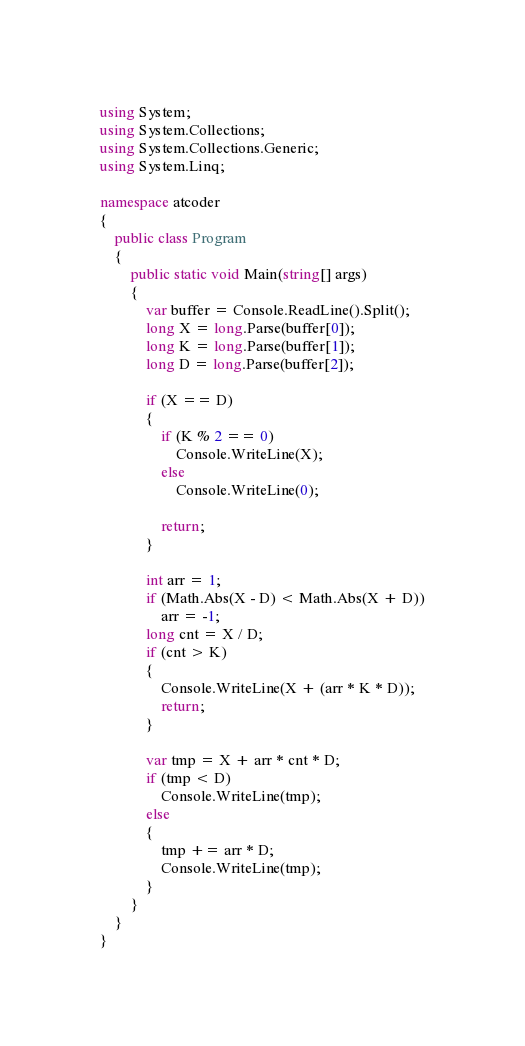<code> <loc_0><loc_0><loc_500><loc_500><_C#_>using System;
using System.Collections;
using System.Collections.Generic;
using System.Linq;

namespace atcoder
{
    public class Program
    {
        public static void Main(string[] args)
        {
            var buffer = Console.ReadLine().Split();
            long X = long.Parse(buffer[0]);
            long K = long.Parse(buffer[1]);
            long D = long.Parse(buffer[2]);

            if (X == D)
            {
                if (K % 2 == 0)
                    Console.WriteLine(X);
                else
                    Console.WriteLine(0);

                return;
            }

            int arr = 1;
            if (Math.Abs(X - D) < Math.Abs(X + D))
                arr = -1;
            long cnt = X / D;
            if (cnt > K)
            {
                Console.WriteLine(X + (arr * K * D));
                return;
            }

            var tmp = X + arr * cnt * D;
            if (tmp < D)
                Console.WriteLine(tmp);
            else
            {
                tmp += arr * D;
                Console.WriteLine(tmp);
            }
        }
    }
}
</code> 